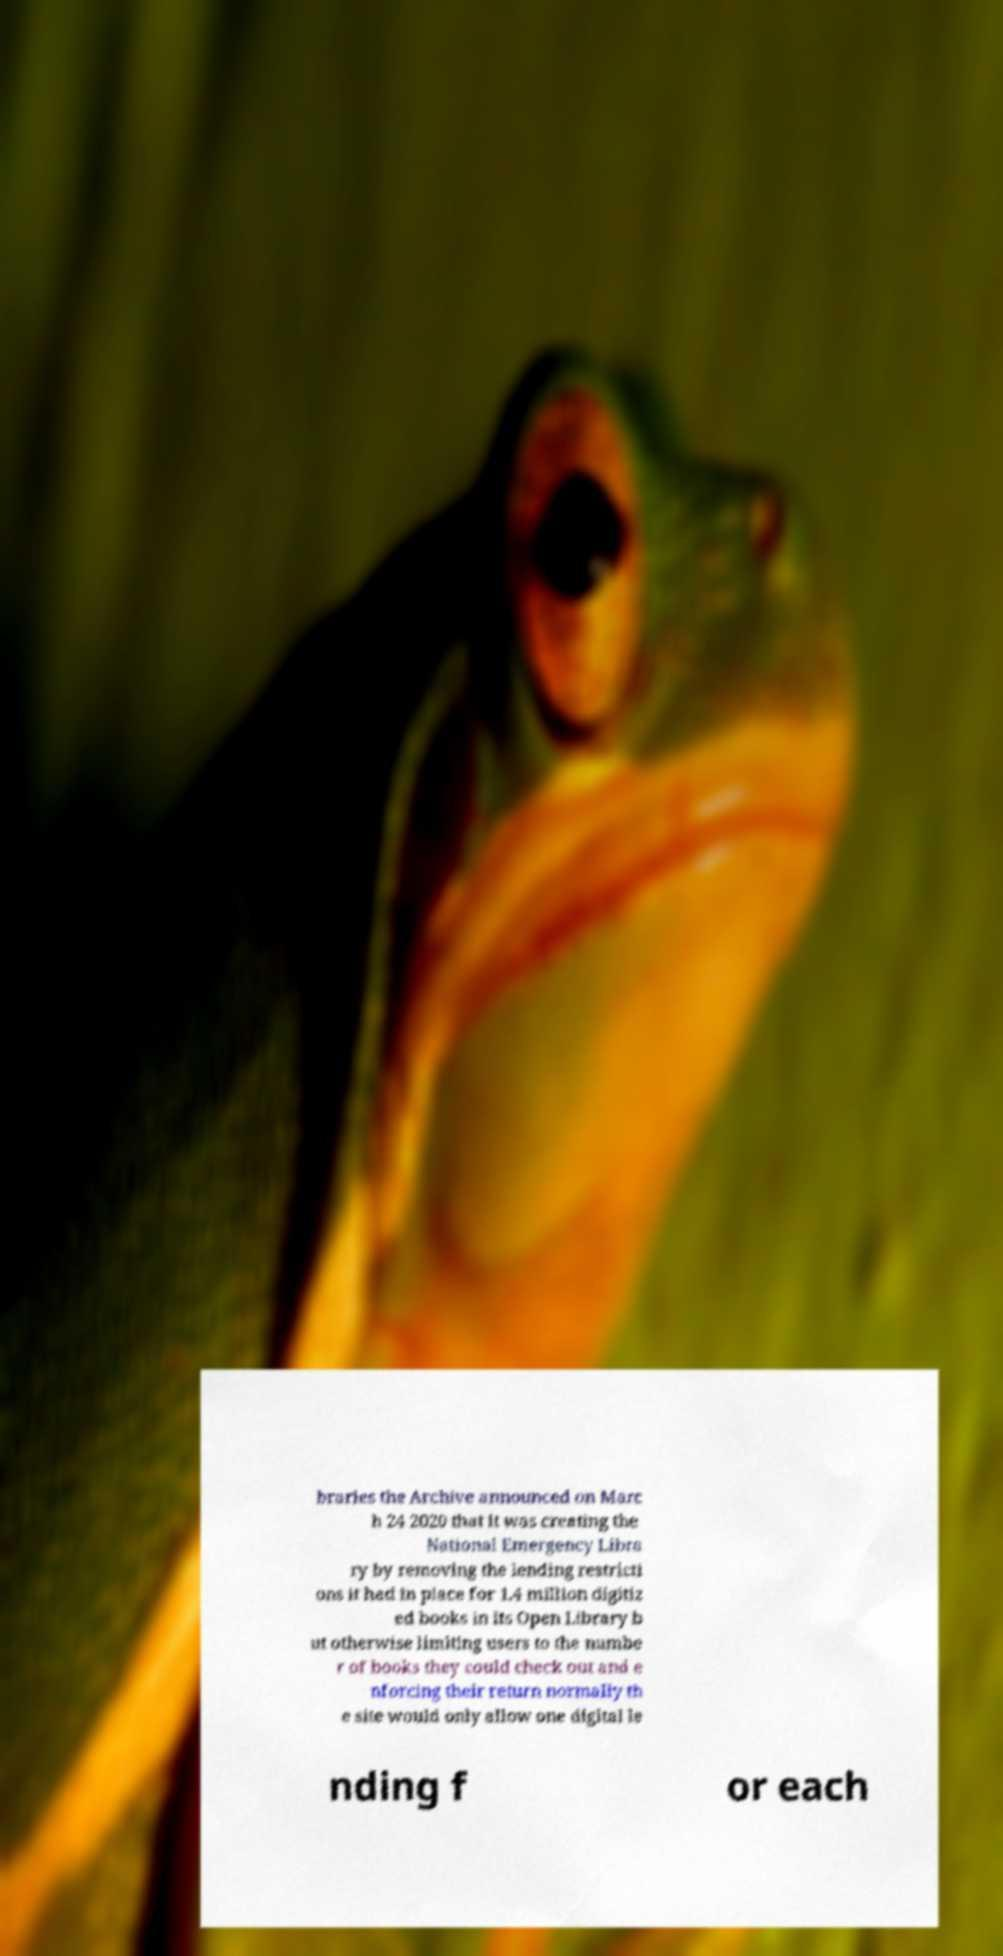Please read and relay the text visible in this image. What does it say? braries the Archive announced on Marc h 24 2020 that it was creating the National Emergency Libra ry by removing the lending restricti ons it had in place for 1.4 million digitiz ed books in its Open Library b ut otherwise limiting users to the numbe r of books they could check out and e nforcing their return normally th e site would only allow one digital le nding f or each 